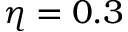Convert formula to latex. <formula><loc_0><loc_0><loc_500><loc_500>\eta = 0 . 3</formula> 